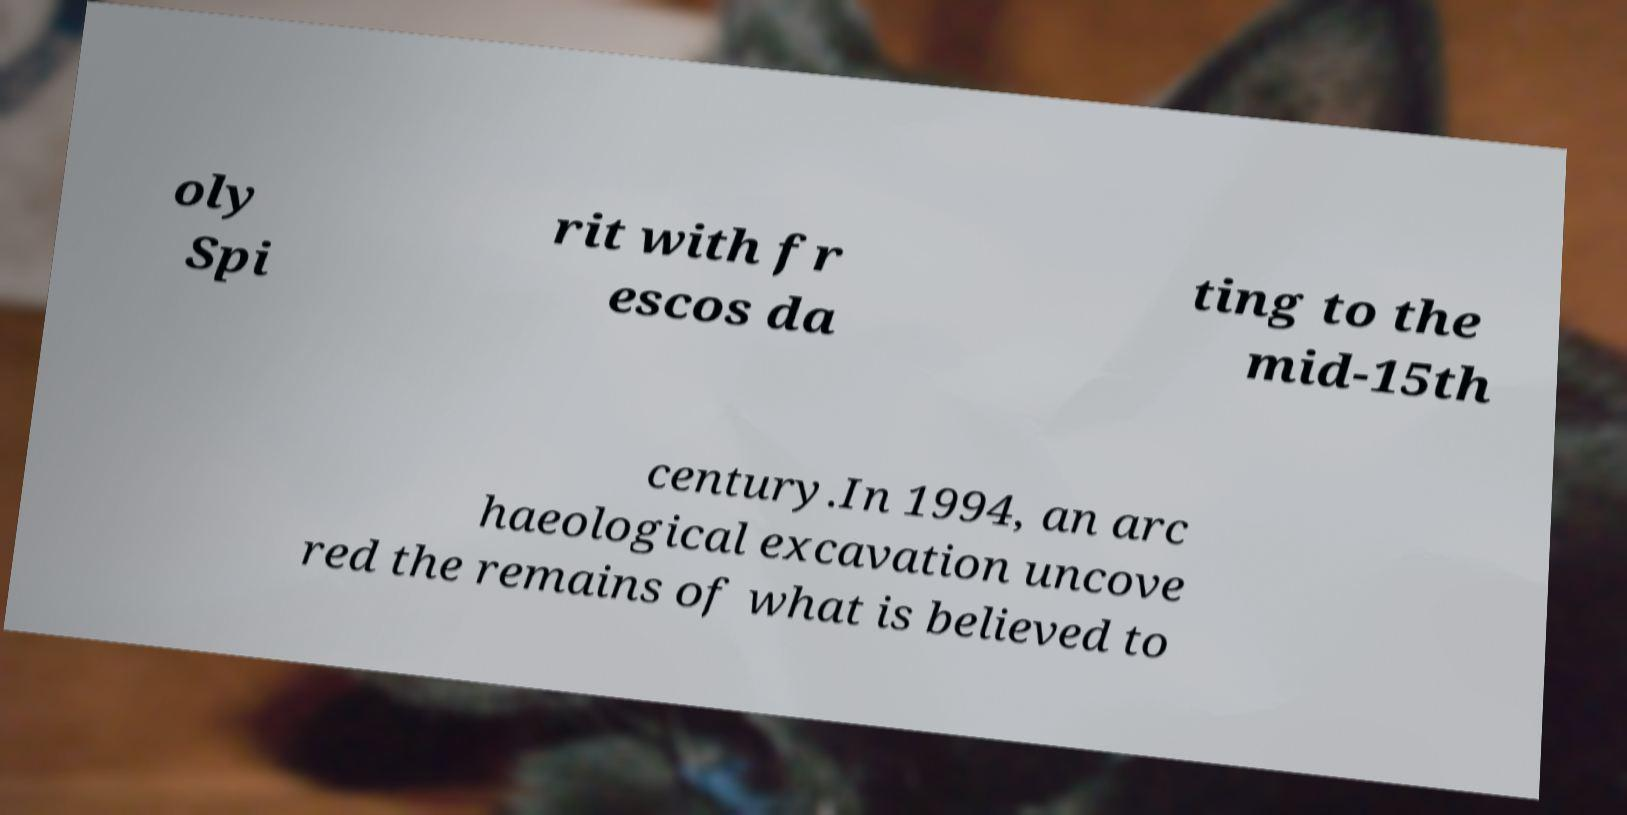Could you assist in decoding the text presented in this image and type it out clearly? oly Spi rit with fr escos da ting to the mid-15th century.In 1994, an arc haeological excavation uncove red the remains of what is believed to 